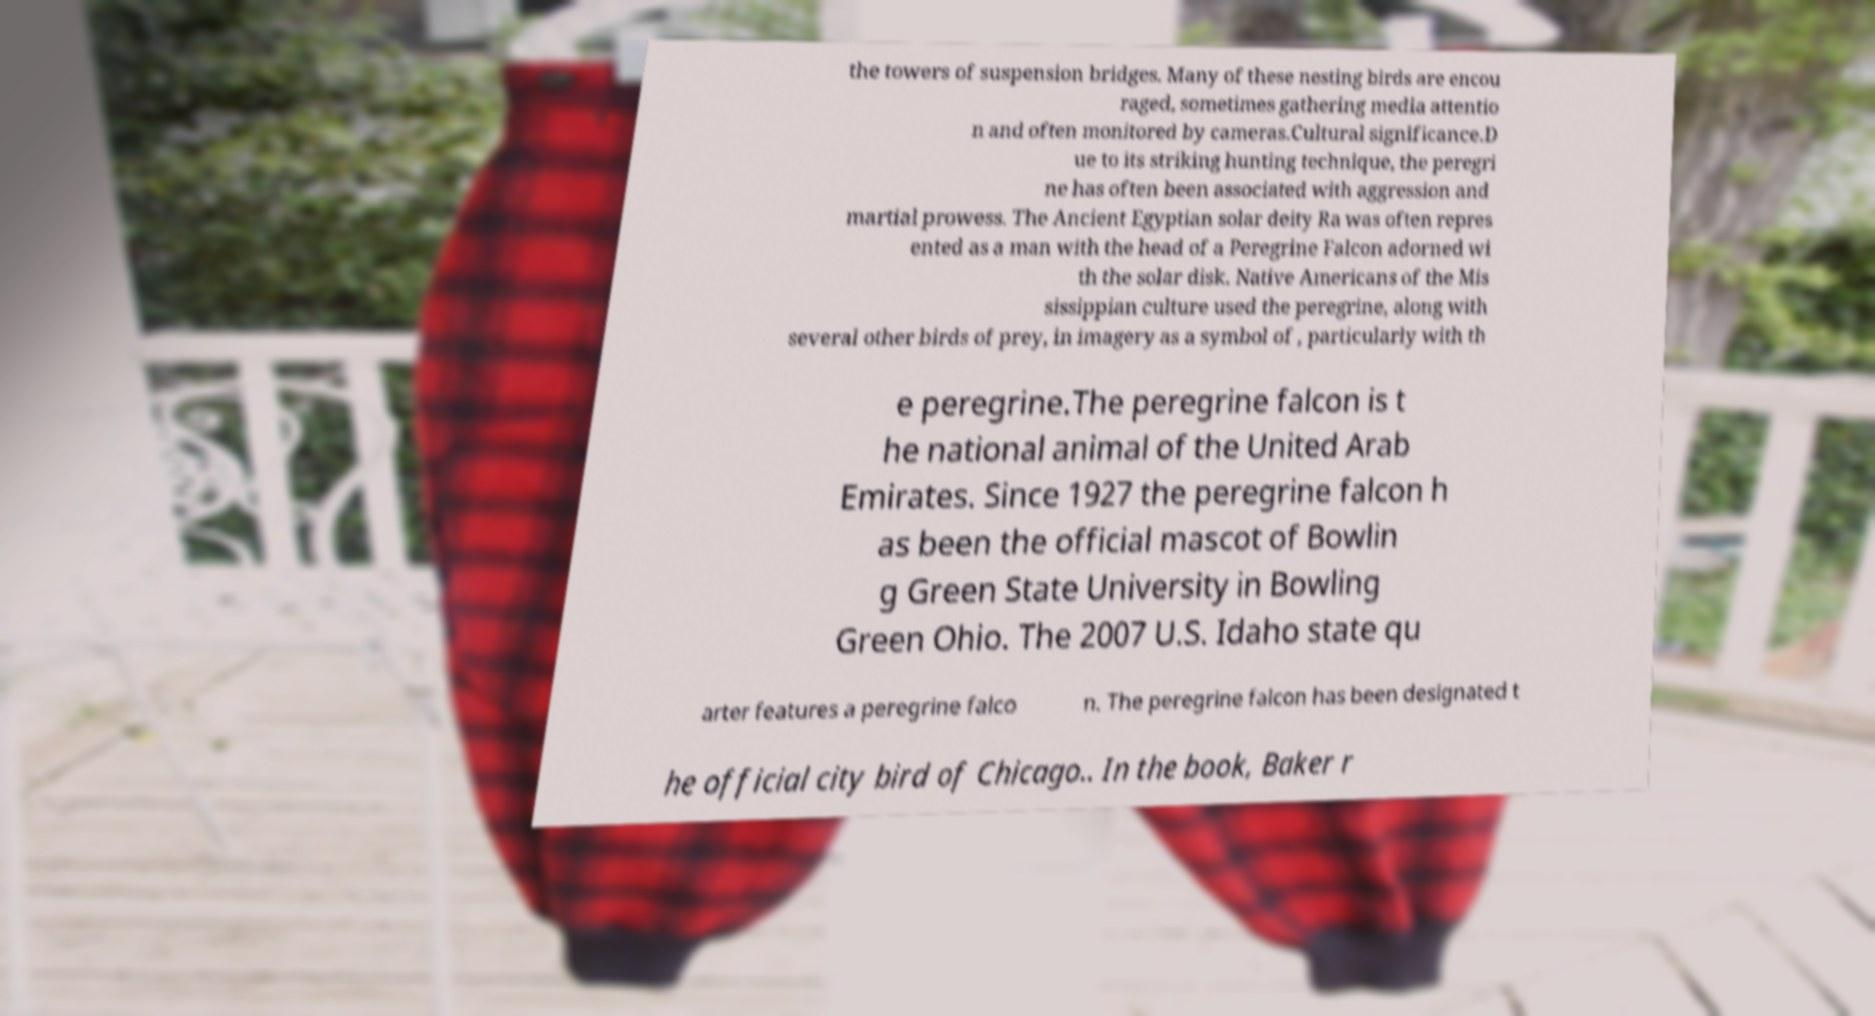Could you assist in decoding the text presented in this image and type it out clearly? the towers of suspension bridges. Many of these nesting birds are encou raged, sometimes gathering media attentio n and often monitored by cameras.Cultural significance.D ue to its striking hunting technique, the peregri ne has often been associated with aggression and martial prowess. The Ancient Egyptian solar deity Ra was often repres ented as a man with the head of a Peregrine Falcon adorned wi th the solar disk. Native Americans of the Mis sissippian culture used the peregrine, along with several other birds of prey, in imagery as a symbol of , particularly with th e peregrine.The peregrine falcon is t he national animal of the United Arab Emirates. Since 1927 the peregrine falcon h as been the official mascot of Bowlin g Green State University in Bowling Green Ohio. The 2007 U.S. Idaho state qu arter features a peregrine falco n. The peregrine falcon has been designated t he official city bird of Chicago.. In the book, Baker r 